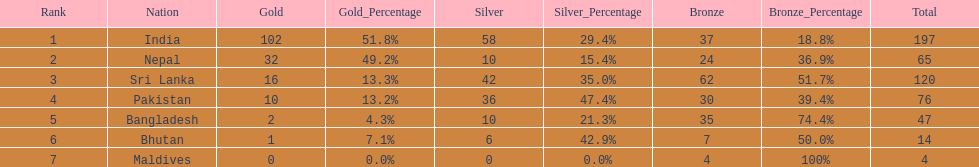How many more gold medals has nepal won than pakistan? 22. 